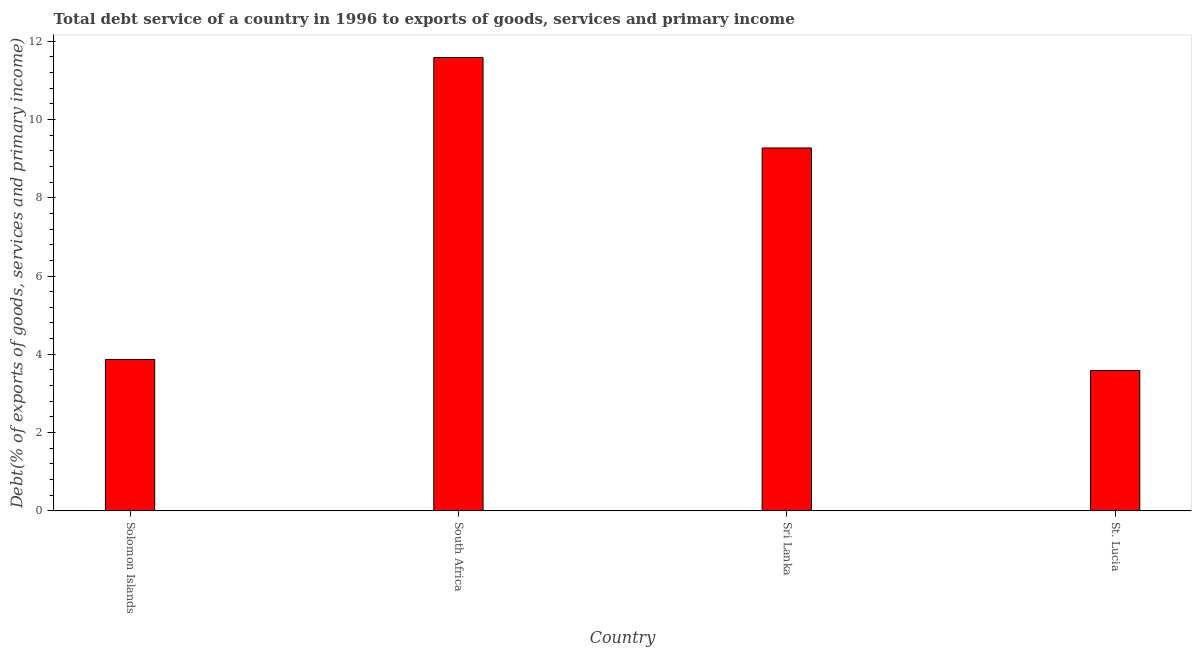Does the graph contain grids?
Keep it short and to the point. No. What is the title of the graph?
Keep it short and to the point. Total debt service of a country in 1996 to exports of goods, services and primary income. What is the label or title of the X-axis?
Your answer should be compact. Country. What is the label or title of the Y-axis?
Keep it short and to the point. Debt(% of exports of goods, services and primary income). What is the total debt service in St. Lucia?
Your answer should be very brief. 3.59. Across all countries, what is the maximum total debt service?
Keep it short and to the point. 11.58. Across all countries, what is the minimum total debt service?
Offer a very short reply. 3.59. In which country was the total debt service maximum?
Your answer should be compact. South Africa. In which country was the total debt service minimum?
Provide a succinct answer. St. Lucia. What is the sum of the total debt service?
Make the answer very short. 28.31. What is the difference between the total debt service in Solomon Islands and Sri Lanka?
Offer a very short reply. -5.41. What is the average total debt service per country?
Offer a terse response. 7.08. What is the median total debt service?
Offer a very short reply. 6.57. In how many countries, is the total debt service greater than 2 %?
Provide a short and direct response. 4. What is the ratio of the total debt service in Solomon Islands to that in Sri Lanka?
Provide a short and direct response. 0.42. Is the total debt service in Solomon Islands less than that in Sri Lanka?
Offer a terse response. Yes. What is the difference between the highest and the second highest total debt service?
Your response must be concise. 2.31. What is the difference between the highest and the lowest total debt service?
Offer a terse response. 8. In how many countries, is the total debt service greater than the average total debt service taken over all countries?
Make the answer very short. 2. How many bars are there?
Provide a short and direct response. 4. What is the difference between two consecutive major ticks on the Y-axis?
Your answer should be compact. 2. What is the Debt(% of exports of goods, services and primary income) in Solomon Islands?
Keep it short and to the point. 3.87. What is the Debt(% of exports of goods, services and primary income) of South Africa?
Provide a succinct answer. 11.58. What is the Debt(% of exports of goods, services and primary income) of Sri Lanka?
Your answer should be very brief. 9.27. What is the Debt(% of exports of goods, services and primary income) in St. Lucia?
Ensure brevity in your answer.  3.59. What is the difference between the Debt(% of exports of goods, services and primary income) in Solomon Islands and South Africa?
Keep it short and to the point. -7.72. What is the difference between the Debt(% of exports of goods, services and primary income) in Solomon Islands and Sri Lanka?
Provide a short and direct response. -5.4. What is the difference between the Debt(% of exports of goods, services and primary income) in Solomon Islands and St. Lucia?
Provide a succinct answer. 0.28. What is the difference between the Debt(% of exports of goods, services and primary income) in South Africa and Sri Lanka?
Keep it short and to the point. 2.31. What is the difference between the Debt(% of exports of goods, services and primary income) in South Africa and St. Lucia?
Ensure brevity in your answer.  8. What is the difference between the Debt(% of exports of goods, services and primary income) in Sri Lanka and St. Lucia?
Provide a short and direct response. 5.69. What is the ratio of the Debt(% of exports of goods, services and primary income) in Solomon Islands to that in South Africa?
Your response must be concise. 0.33. What is the ratio of the Debt(% of exports of goods, services and primary income) in Solomon Islands to that in Sri Lanka?
Your answer should be very brief. 0.42. What is the ratio of the Debt(% of exports of goods, services and primary income) in Solomon Islands to that in St. Lucia?
Your answer should be very brief. 1.08. What is the ratio of the Debt(% of exports of goods, services and primary income) in South Africa to that in Sri Lanka?
Provide a succinct answer. 1.25. What is the ratio of the Debt(% of exports of goods, services and primary income) in South Africa to that in St. Lucia?
Provide a succinct answer. 3.23. What is the ratio of the Debt(% of exports of goods, services and primary income) in Sri Lanka to that in St. Lucia?
Ensure brevity in your answer.  2.59. 